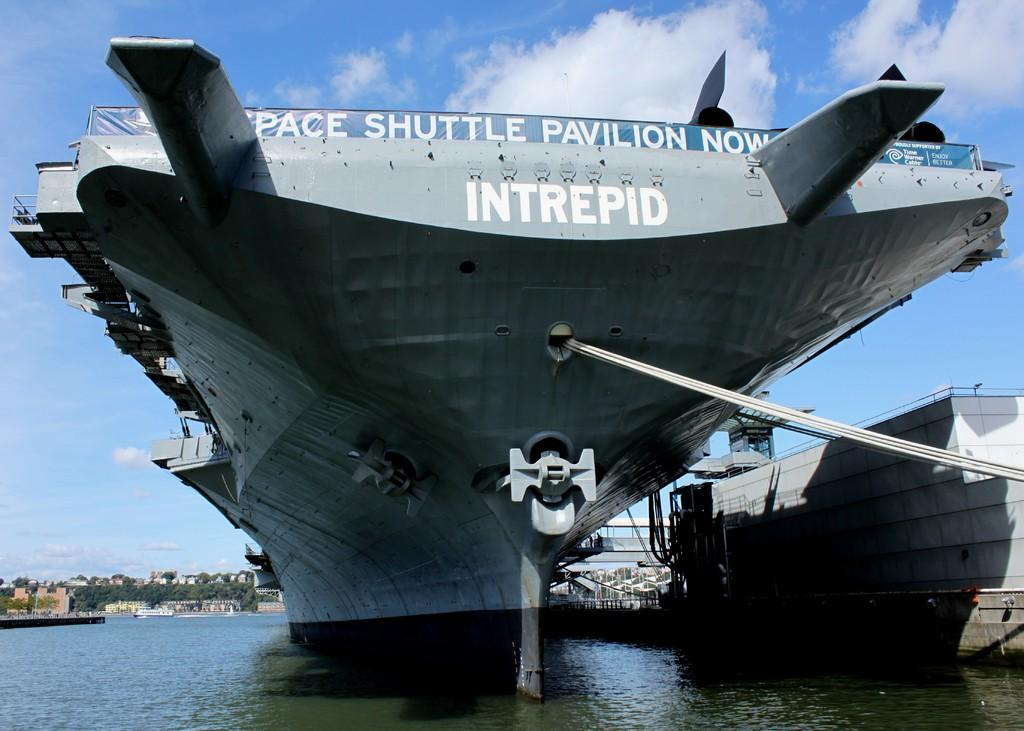<image>
Provide a brief description of the given image. A picture of an aircraft carrier named the INTREPID with a banner saying the Space Shuttle Pavilion is now. 